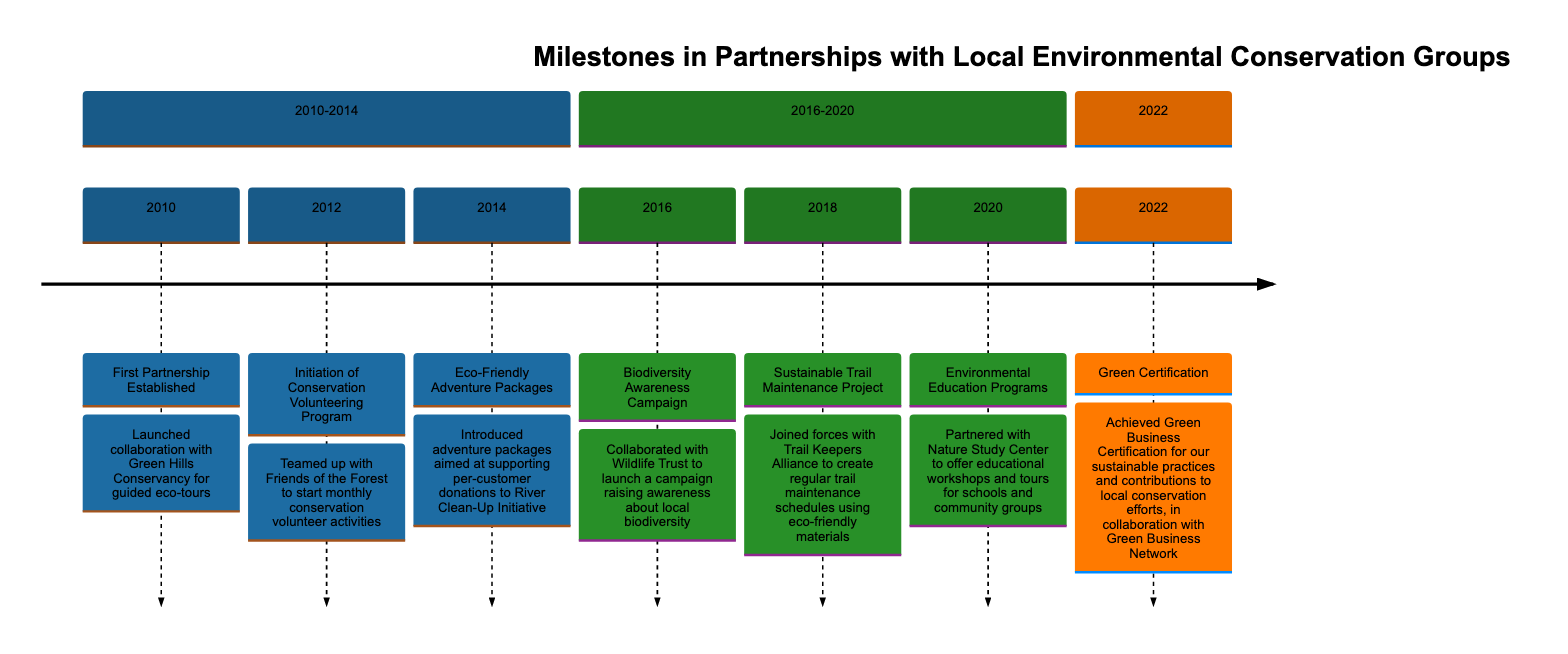What is the first milestone mentioned in the timeline? The timeline starts with the year 2010, which is the first year mentioned. The milestone recorded for this year is "First Partnership Established."
Answer: First Partnership Established How many partnerships were established between 2010 and 2014? During this period, there are three milestones listed: the first partnership in 2010, the initiation of the conservation volunteering program in 2012, and the introduction of eco-friendly adventure packages in 2014. Thus, the total number of partnerships is three.
Answer: 3 What year saw the launch of the Biodiversity Awareness Campaign? The timeline indicates that the Biodiversity Awareness Campaign was launched in 2016, as this milestone falls under the years 2016-2020.
Answer: 2016 What organization collaborated for the Eco-Friendly Adventure Packages? In the timeline, it specifies that the Eco-Friendly Adventure Packages were introduced to support per-customer donations to the River Clean-Up Initiative. Therefore, the organization associated with this milestone is the River Clean-Up Initiative.
Answer: River Clean-Up Initiative What was achieved in 2022? The timeline states that in 2022, the milestone is "Green Certification," which signifies that a certification was achieved related to sustainable practices and contributions to conservation efforts.
Answer: Green Certification What initiative started in 2012? The initiative that began in 2012 is the "Initiation of Conservation Volunteering Program," which involved a partnership with Friends of the Forest for monthly volunteer activities.
Answer: Initiation of Conservation Volunteering Program Which year had a milestone related to environmental education? The timeline shows that the milestone related to environmental education was in 2020, when a partnership was formed with Nature Study Center to offer educational workshops and tours.
Answer: 2020 How many milestones were recorded in the 2016-2020 section? In the designated section from 2016-2020, three milestones are recorded: the Biodiversity Awareness Campaign (2016), the Sustainable Trail Maintenance Project (2018), and the Environmental Education Programs (2020). Thus, the total is three.
Answer: 3 